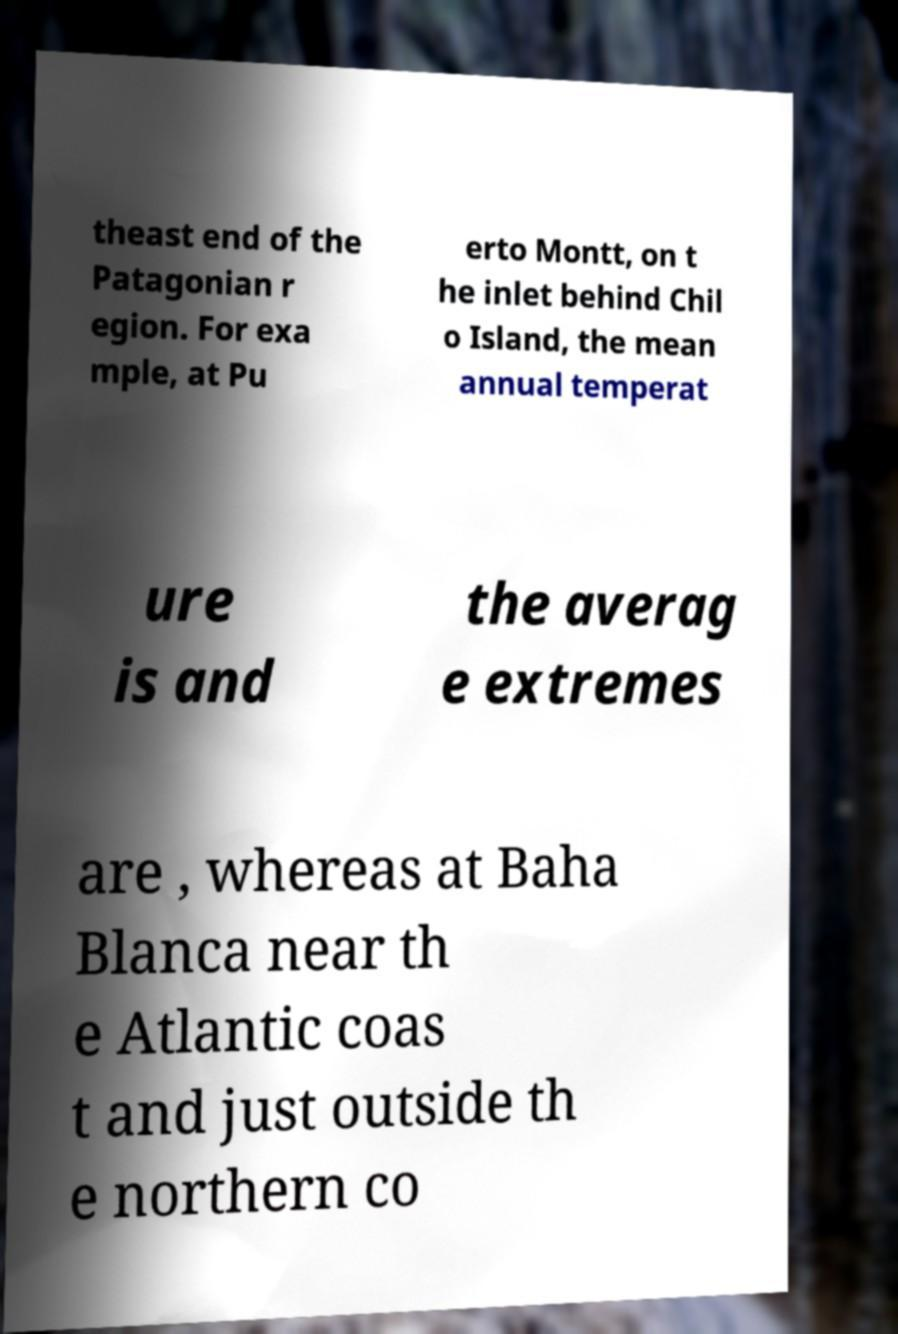Can you accurately transcribe the text from the provided image for me? theast end of the Patagonian r egion. For exa mple, at Pu erto Montt, on t he inlet behind Chil o Island, the mean annual temperat ure is and the averag e extremes are , whereas at Baha Blanca near th e Atlantic coas t and just outside th e northern co 